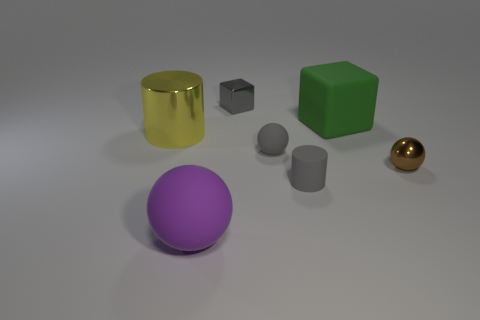Is the number of small blocks behind the big green cube less than the number of big metal objects?
Your answer should be compact. No. What size is the shiny object left of the matte object on the left side of the tiny gray shiny block?
Provide a succinct answer. Large. How many objects are either large yellow things or small red matte things?
Your response must be concise. 1. Are there any small metal cubes of the same color as the rubber cylinder?
Give a very brief answer. Yes. Are there fewer blue metallic balls than green matte cubes?
Ensure brevity in your answer.  Yes. What number of things are either tiny gray blocks or gray things in front of the large yellow metal thing?
Your answer should be very brief. 3. Are there any tiny gray balls made of the same material as the big purple thing?
Give a very brief answer. Yes. What material is the gray sphere that is the same size as the brown object?
Offer a terse response. Rubber. The yellow thing that is in front of the small metal thing left of the big cube is made of what material?
Provide a succinct answer. Metal. Do the shiny thing on the right side of the tiny rubber cylinder and the green thing have the same shape?
Your response must be concise. No. 